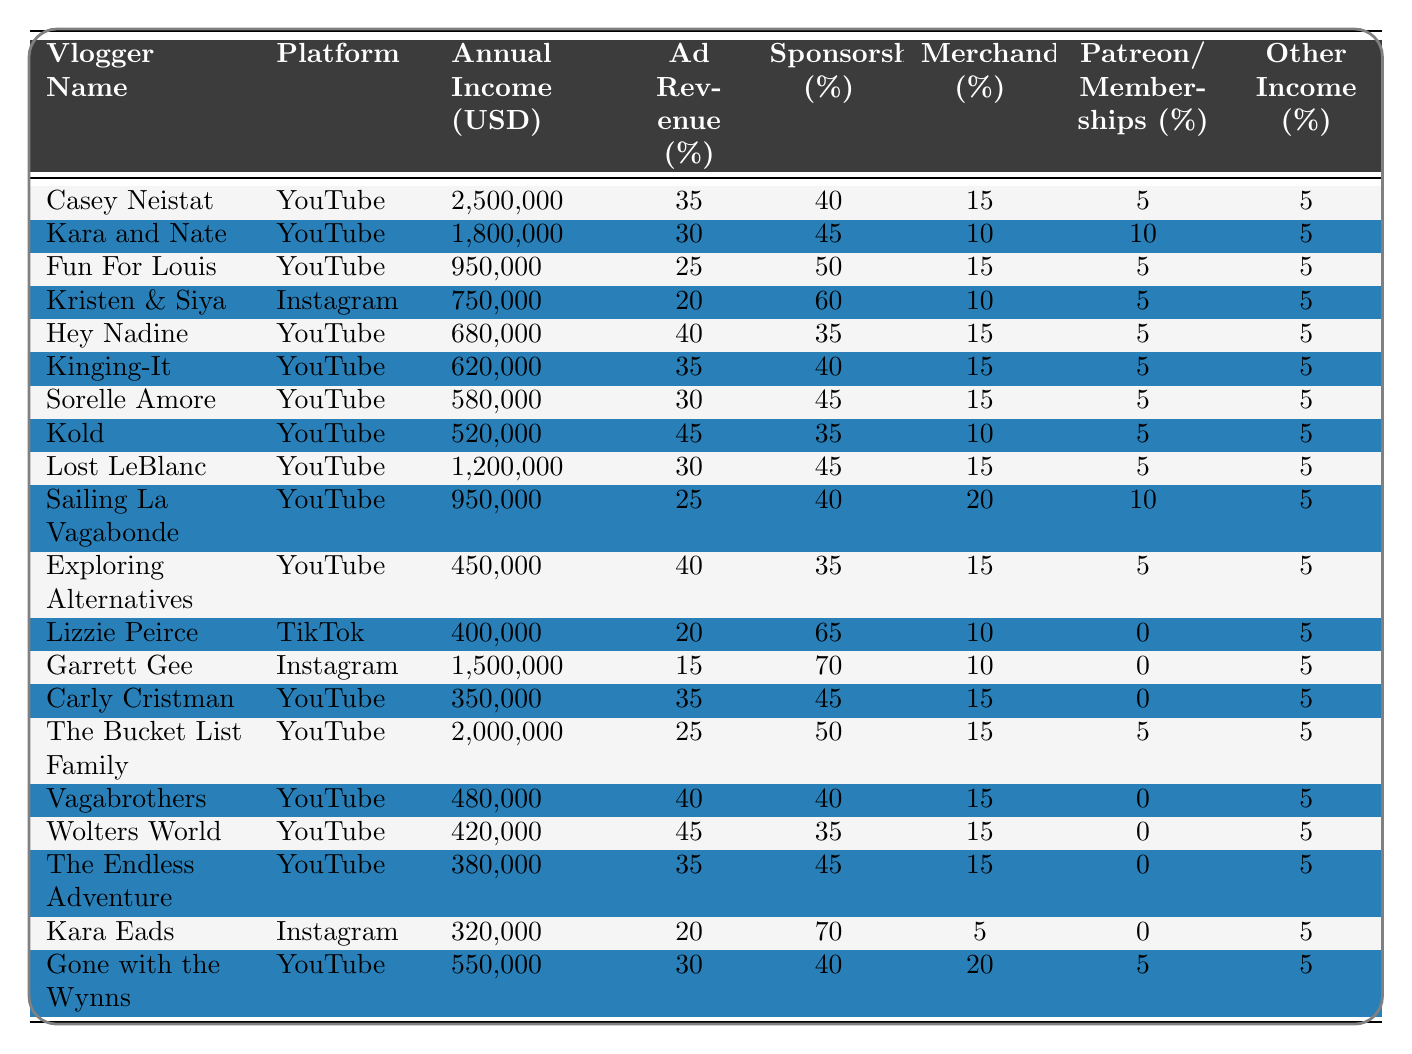What is the highest annual income among the vloggers listed? The highest annual income can be found by scanning through the "Annual Income (USD)" column to identify the maximum value. After reviewing the data, Casey Neistat has the highest income of 2,500,000 USD.
Answer: 2,500,000 USD Which platform has the most vloggers listed in the table? By counting the entries under the "Platform" column, YouTube appears most frequently. Counting them gives 15 for YouTube, while Instagram has 3 and TikTok has 1.
Answer: YouTube What percentage of income does Lost LeBlanc make from sponsorships? To find the percentage of income from sponsorships for Lost LeBlanc, locate the row associated with their name and refer to the "Sponsorships (%)" column, which shows 45%.
Answer: 45% Calculate the average annual income of the vloggers. To compute the average income, sum up all the annual incomes provided: 2,500,000 + 1,800,000 + 950,000 + 750,000 + 680,000 + 620,000 + 580,000 + 520,000 + 1,200,000 + 950,000 + 450,000 + 400,000 + 1,500,000 + 350,000 + 2,000,000 + 480,000 + 420,000 + 380,000 + 320,000 + 550,000 = 14,620,000 USD. There are 20 vloggers, so the average is 14,620,000 / 20 = 731,000 USD.
Answer: 731,000 USD True or False: All vloggers have at least 5% income from other sources. To answer this, review the "Other Income (%)" column. Lizzie Peirce and Garrett Gee both have 5%, while others have 0%. Therefore, not all vloggers have at least 5%.
Answer: False Which vlogger earns the least, and what is their income? The "Annual Income (USD)" column shows the values, and upon scanning, the lowest income is listed for Kara Eads with an income of 320,000 USD.
Answer: Kara Eads, 320,000 USD How does the annual income of Garrett Gee compare to that of Sailing La Vagabonde? To make the comparison, look at the respective incomes: Garrett Gee earns 1,500,000 USD, while Sailing La Vagabonde earns 950,000 USD. The difference is 1,500,000 - 950,000 = 550,000 USD indicating Garrett Gee earns 550,000 USD more.
Answer: Garrett Gee earns 550,000 USD more What portion of Hey Nadine's income comes from ad revenue? Locate Hey Nadine in the table and check the "Ad Revenue (%)" column, which shows a value of 40%. To find the dollar amount, calculate 40% of 680,000 USD (0.40 * 680000 = 272,000 USD).
Answer: 272,000 USD Which two vloggers have the highest combined income? First, identify the top two incomes: Casey Neistat (2,500,000 USD) and The Bucket List Family (2,000,000 USD). Their combined income is 2,500,000 + 2,000,000 = 4,500,000 USD.
Answer: 4,500,000 USD How many vloggers earn more than 1 million USD annually? Count the entries in the "Annual Income (USD)" column that exceed 1,000,000 USD. After checking, 4 vloggers meet this criterion: Casey Neistat, The Bucket List Family, Garrett Gee, and Lost LeBlanc.
Answer: 4 If you add together all the percentages of ad revenue for the top five vloggers, what total do you get? The top five vloggers' ad revenue percentages are: 35% (Casey Neistat), 30% (Kara and Nate), 25% (Fun For Louis), 20% (Kristen & Siya), and 40% (Hey Nadine), summing these gives 35 + 30 + 25 + 20 + 40 = 150%.
Answer: 150% 